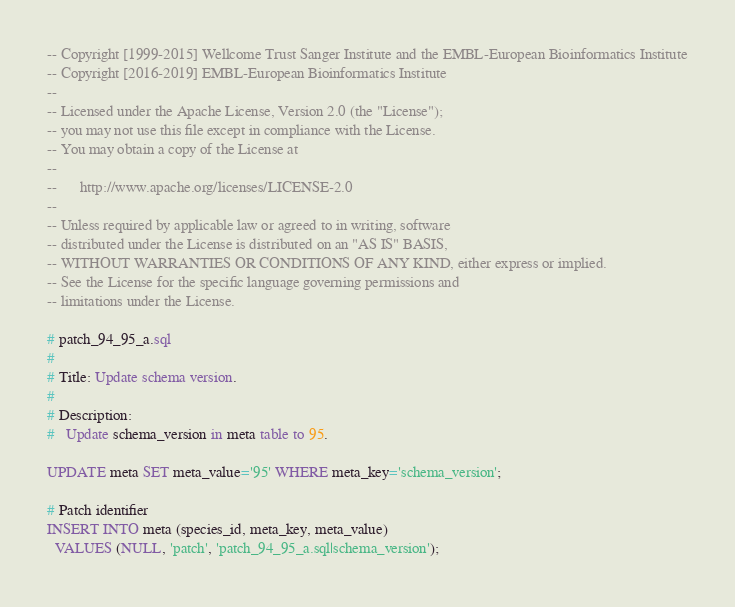Convert code to text. <code><loc_0><loc_0><loc_500><loc_500><_SQL_>-- Copyright [1999-2015] Wellcome Trust Sanger Institute and the EMBL-European Bioinformatics Institute
-- Copyright [2016-2019] EMBL-European Bioinformatics Institute
--
-- Licensed under the Apache License, Version 2.0 (the "License");
-- you may not use this file except in compliance with the License.
-- You may obtain a copy of the License at
--
--      http://www.apache.org/licenses/LICENSE-2.0
--
-- Unless required by applicable law or agreed to in writing, software
-- distributed under the License is distributed on an "AS IS" BASIS,
-- WITHOUT WARRANTIES OR CONDITIONS OF ANY KIND, either express or implied.
-- See the License for the specific language governing permissions and
-- limitations under the License.

# patch_94_95_a.sql
#
# Title: Update schema version.
#
# Description:
#   Update schema_version in meta table to 95.

UPDATE meta SET meta_value='95' WHERE meta_key='schema_version';

# Patch identifier
INSERT INTO meta (species_id, meta_key, meta_value)
  VALUES (NULL, 'patch', 'patch_94_95_a.sql|schema_version');
</code> 